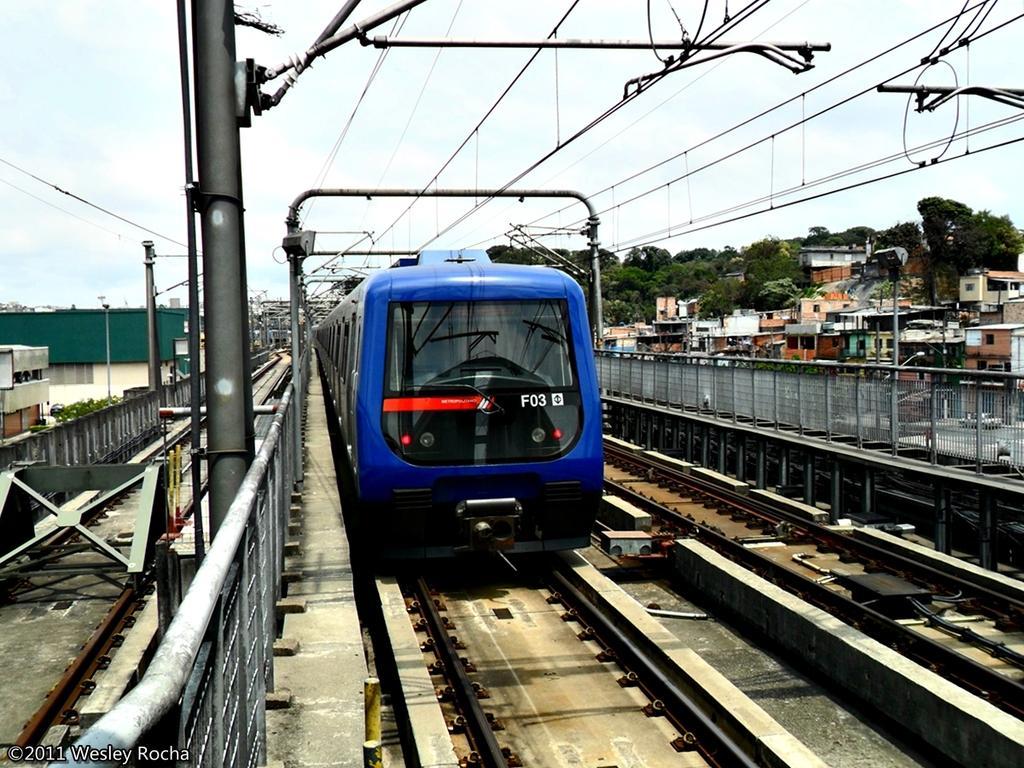Could you give a brief overview of what you see in this image? There is a blue color train on the railway track. On the train there is something written. On the left side there are railings, poles and buildings. And on the right side there is a railway track, railings, buildings, trees and poles. And there are electric wires above the train. 